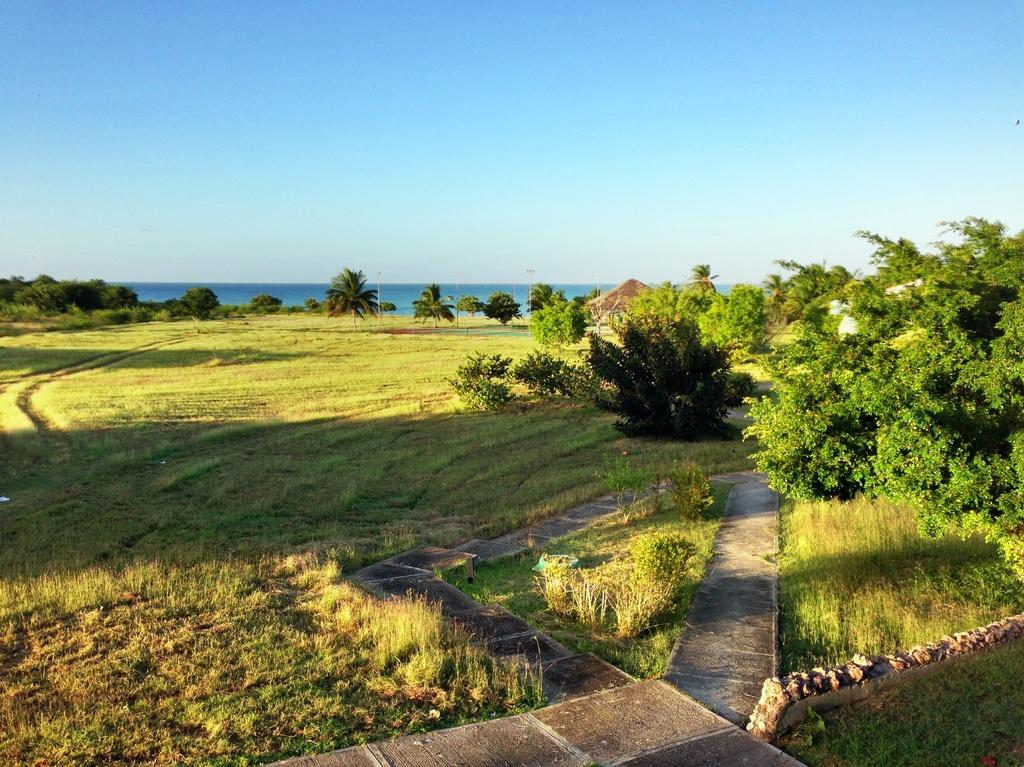What type of vegetation can be seen in the image? There are trees and grass in the image. What else can be found in the image besides vegetation? There are houses and plants in the image. What is visible in the background of the image? The sky is visible in the background of the image. What type of insurance policy is being discussed in the image? There is no discussion of insurance policies in the image; it features trees, grass, houses, plants, and the sky. Can you see someone's elbow in the image? There are no people visible in the image, so it is not possible to see anyone's elbow. 